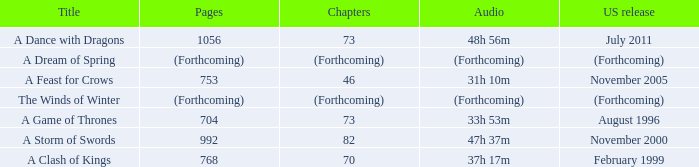Which audio has a Title of a storm of swords? 47h 37m. 